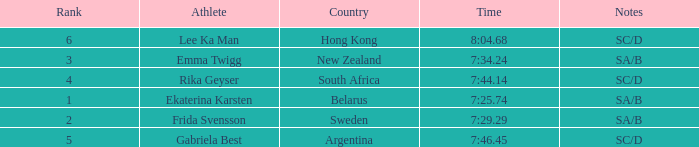What is the total rank for the athlete that had a race time of 7:34.24? 1.0. Parse the table in full. {'header': ['Rank', 'Athlete', 'Country', 'Time', 'Notes'], 'rows': [['6', 'Lee Ka Man', 'Hong Kong', '8:04.68', 'SC/D'], ['3', 'Emma Twigg', 'New Zealand', '7:34.24', 'SA/B'], ['4', 'Rika Geyser', 'South Africa', '7:44.14', 'SC/D'], ['1', 'Ekaterina Karsten', 'Belarus', '7:25.74', 'SA/B'], ['2', 'Frida Svensson', 'Sweden', '7:29.29', 'SA/B'], ['5', 'Gabriela Best', 'Argentina', '7:46.45', 'SC/D']]} 